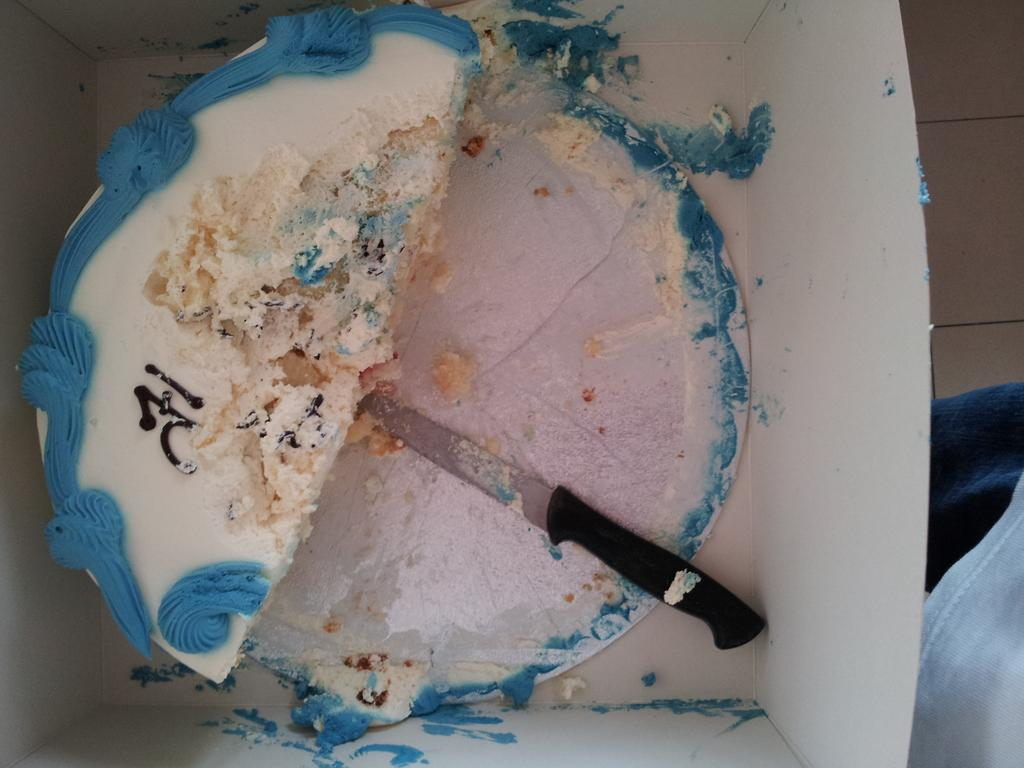What is inside the box that is visible in the image? There is a cake in a box in the image. What object can be used to cut the cake in the image? There is a knife in the image. Where was the image taken? The image was taken in a room. What type of jewel is hidden inside the cake in the image? There is no jewel hidden inside the cake in the image. 